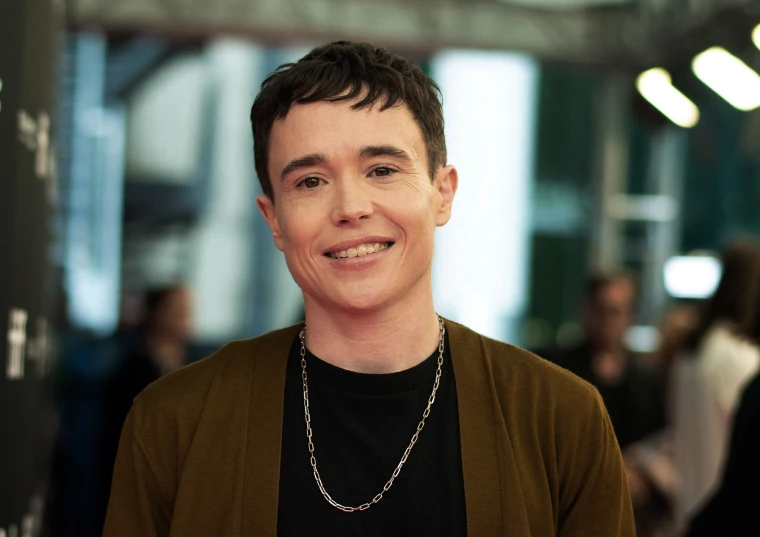Imagine this person is about to give an important speech. What might they be thinking? As they prepare to give an important speech, they might be feeling a mix of excitement and nervousness. Thoughts of the key points they want to convey, anticipation of the audience's reaction, and a desire to make a meaningful impact could be swirling in their mind. Despite the nerves, their confident attire and warm smile suggest that they are ready to connect with the audience. 